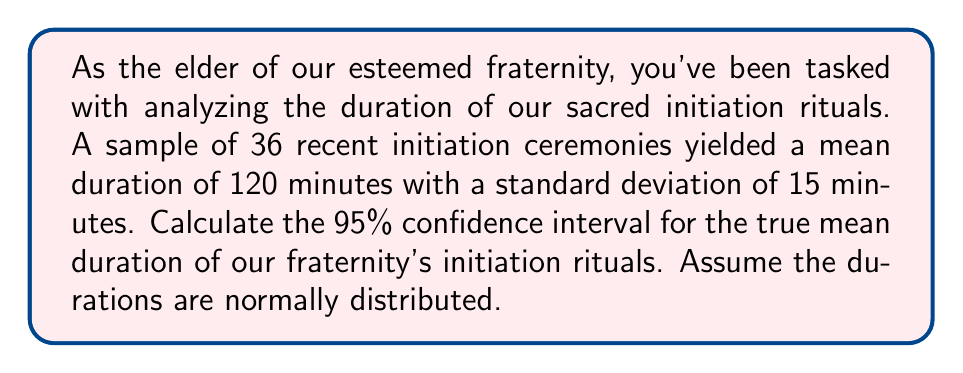Teach me how to tackle this problem. Let's approach this step-by-step:

1) We're given:
   - Sample size: $n = 36$
   - Sample mean: $\bar{x} = 120$ minutes
   - Sample standard deviation: $s = 15$ minutes
   - Confidence level: 95%

2) The formula for the confidence interval of a mean is:

   $$\bar{x} \pm t_{\alpha/2} \cdot \frac{s}{\sqrt{n}}$$

   where $t_{\alpha/2}$ is the t-value for the given confidence level and degrees of freedom.

3) Degrees of freedom: $df = n - 1 = 36 - 1 = 35$

4) For a 95% confidence interval, $\alpha = 0.05$, and $\alpha/2 = 0.025$

5) From a t-table or calculator, we find $t_{0.025, 35} \approx 2.030$

6) Now, let's calculate the margin of error:

   $$\text{Margin of Error} = t_{\alpha/2} \cdot \frac{s}{\sqrt{n}} = 2.030 \cdot \frac{15}{\sqrt{36}} \approx 5.075$$

7) Therefore, the 95% confidence interval is:

   $$120 \pm 5.075$$

8) This gives us the interval (114.925, 125.075)

Thus, we can be 95% confident that the true mean duration of our fraternity's initiation rituals falls between 114.925 and 125.075 minutes.
Answer: (114.925, 125.075) minutes 